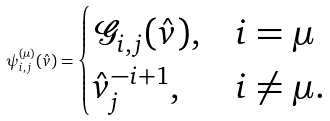Convert formula to latex. <formula><loc_0><loc_0><loc_500><loc_500>\psi _ { i , j } ^ { ( \mu ) } ( \hat { v } ) = \begin{cases} \mathcal { G } _ { i , j } ( \hat { v } ) , & i = \mu \\ \hat { v } _ { j } ^ { - i + 1 } , & i \neq \mu . \end{cases}</formula> 